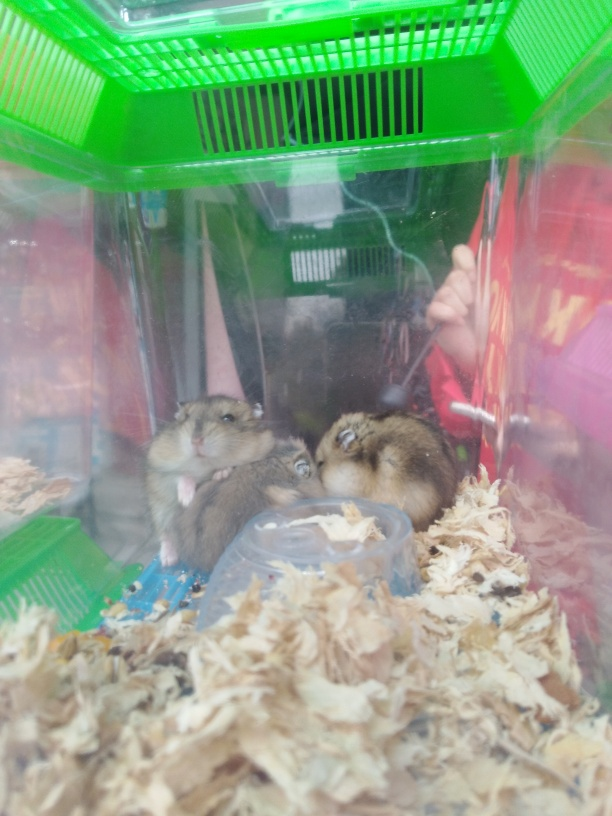Is the overall sharpness of the image bad? While the image does exhibit some blurriness, likely due to a combination of motion blur, low lighting conditions, and possibly a smudge on the camera lens, it is not so severe as to render the image unusable. The subjects, which appear to be small rodents, possibly hamsters, positioned in a plastic enclosure, are still identifiable. However, for optimal clarity, a higher resolution or different camera settings could enhance the sharpness of the image. 